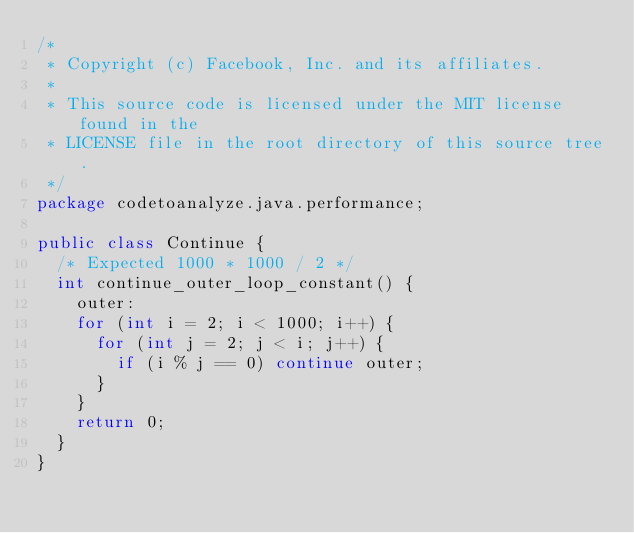Convert code to text. <code><loc_0><loc_0><loc_500><loc_500><_Java_>/*
 * Copyright (c) Facebook, Inc. and its affiliates.
 *
 * This source code is licensed under the MIT license found in the
 * LICENSE file in the root directory of this source tree.
 */
package codetoanalyze.java.performance;

public class Continue {
  /* Expected 1000 * 1000 / 2 */
  int continue_outer_loop_constant() {
    outer:
    for (int i = 2; i < 1000; i++) {
      for (int j = 2; j < i; j++) {
        if (i % j == 0) continue outer;
      }
    }
    return 0;
  }
}
</code> 